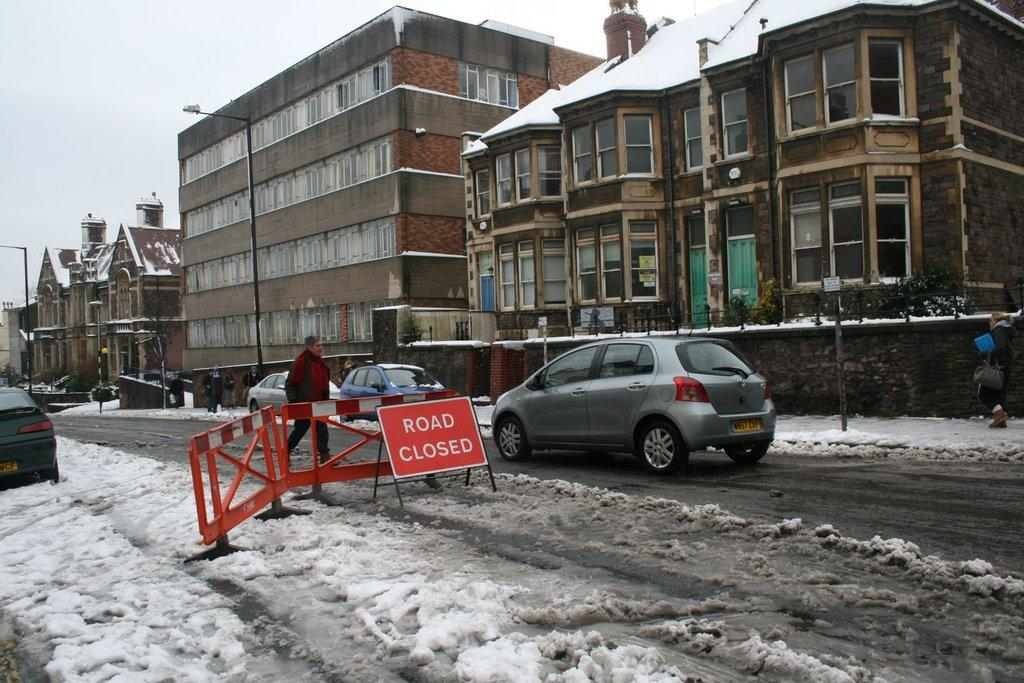What type of structures can be seen in the image? There are buildings in the image. What objects are present alongside the buildings? There are poles in the image. What mode of transportation can be seen on the road at the bottom of the image? There are cars on the road at the bottom of the image. What is the purpose of the board visible in the image? The purpose of the board is not specified, but it is visible in the image. Can you identify any living beings in the image? Yes, there are people in the image. What is the weather like in the image? The weather is snowy, as snow is visible in the image. What is visible in the background of the image? There is sky visible in the background of the image. What type of flower is growing on the roof of the building in the image? There are no flowers visible on the roof of the building in the image. What type of drug can be seen being sold on the street in the image? There is no indication of any drug sales in the image; it features buildings, poles, cars, a board, people, snow, and sky. 